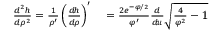<formula> <loc_0><loc_0><loc_500><loc_500>\begin{array} { r l } { \frac { d ^ { 2 } h } { d \rho ^ { 2 } } = \frac { 1 } { \rho ^ { \prime } } \left ( \frac { d h } { d \rho } \right ) ^ { \prime } } & = \frac { 2 e ^ { - \varphi / 2 } } { \varphi ^ { \prime } } \frac { d } { d u } \sqrt { \frac { 4 } { \varphi ^ { 2 } } - 1 } } \end{array}</formula> 